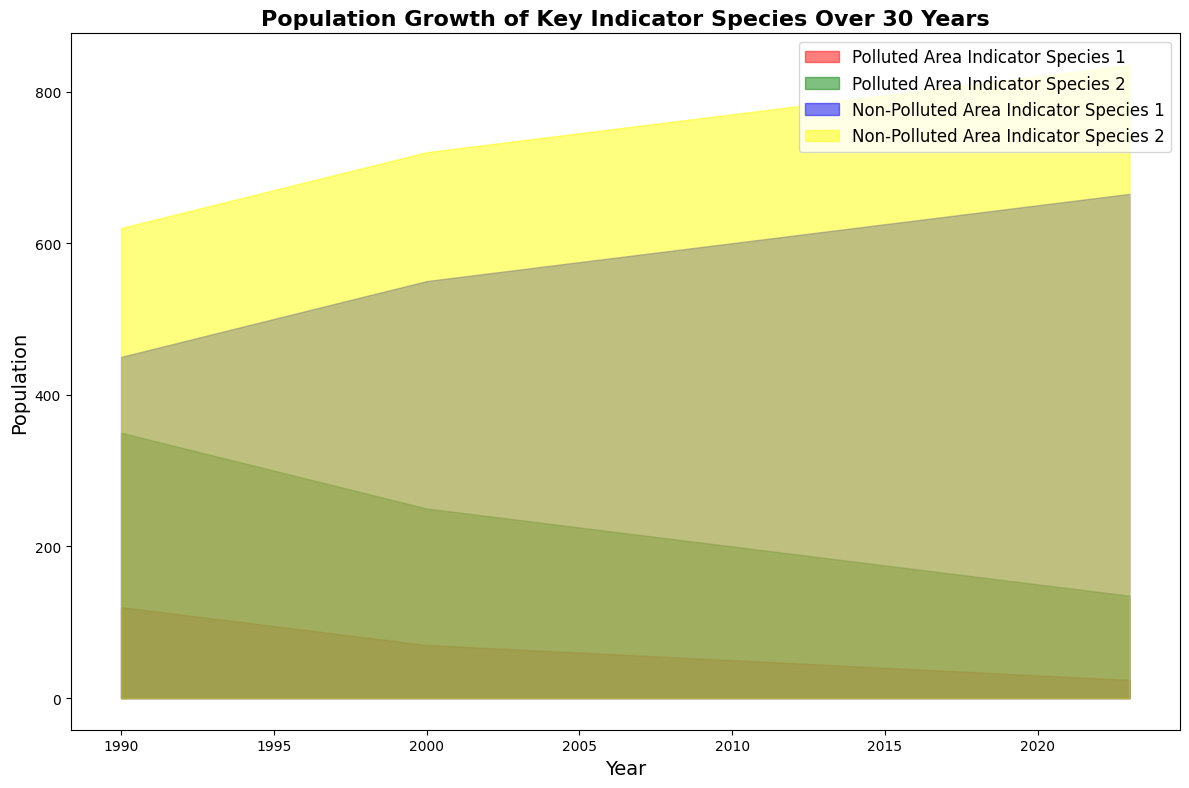what trend is observed in the populations of indicator species in polluted areas over the past 30 years? The population of both Polluted Area Indicator Species 1 and Polluted Area Indicator Species 2 shows a steady decline. Polluted Area Indicator Species 1 drops from 120 in 1990 to 24 in 2023, and Polluted Area Indicator Species 2 drops from 350 in 1990 to 135 in 2023.
Answer: A steady decline Which indicator species shows the least decline in population in non-polluted areas from 1990 to 2023? To determine this, we calculate the difference in population for both species in non-polluted areas. Non-Polluted Area Indicator Species 1 declines from 450 in 1990 to 665 in 2023 (a difference of 215), and Non-Polluted Area Indicator Species 2 declines from 620 in 1990 to 835 in 2023 (a difference of 215). Both species show the same decline.
Answer: Both species show the same decline Which species had a population of 200 in 2010? In the year 2010, Polluted Area Indicator Species 2 had a population of 200. Referring to the area chart, the green band (Polluted Area Indicator Species 2) intersects the 200 population mark at the year 2010.
Answer: Polluted Area Indicator Species 2 What is the average population of Non-Polluted Area Indicator Species 2 over the past 30 years? To find the average, sum the populations for each year from 1990 to 2023, and divide by the number of years (34). The total sum is (620+630+640+650+660+670+680+690+700+710+720+725+730+735+740+745+750+755+760+765+770+775+780+785+790+795+800+805+810+815+820+825+830+835) = 23775. Dividing by 34, we get 23775 / 34 = approximately 699.26.
Answer: 699.26 By how much does the population of Polluted Area Indicator Species 1 decrease from 1990 to 2023? Subtract the population of Polluted Area Indicator Species 1 in 2023 (24) from its population in 1990 (120). The difference is 120 - 24 = 96.
Answer: 96 Which indicator species in non-polluted areas had the greatest population increase over the 30 years and by how much? Both Non-Polluted Area Indicator Species 1 and Non-Polluted Area Indicator Species 2 increased equally over 30 years. Non-Polluted Area Indicator Species 1 increased from 450 to 665 (215 increase), and Non-Polluted Area Indicator Species 2 from 620 to 835 (215 increase). Both increased by 215.
Answer: Both species by 215 